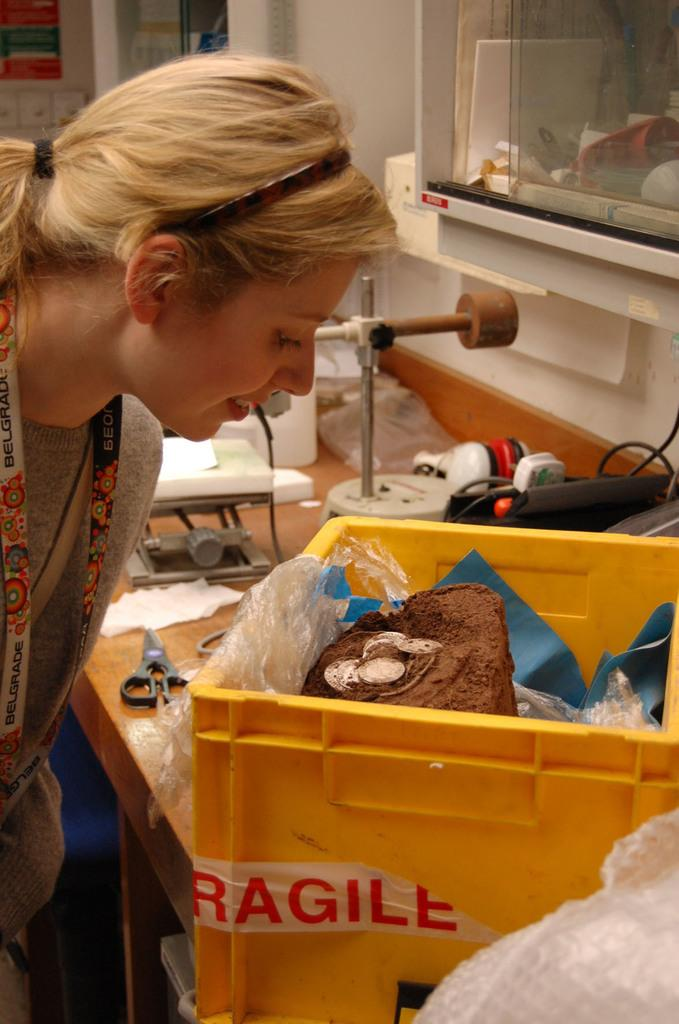<image>
Share a concise interpretation of the image provided. a woman looking into a yellow box with a 'fragile' label on it 